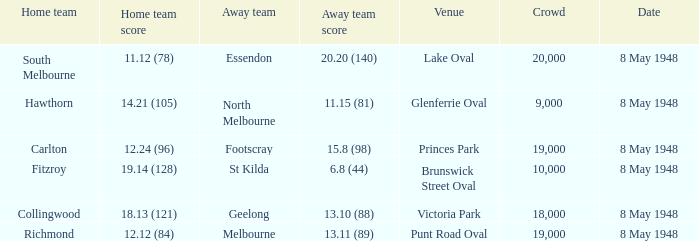Which away team played the home team when they scored 14.21 (105)? North Melbourne. 